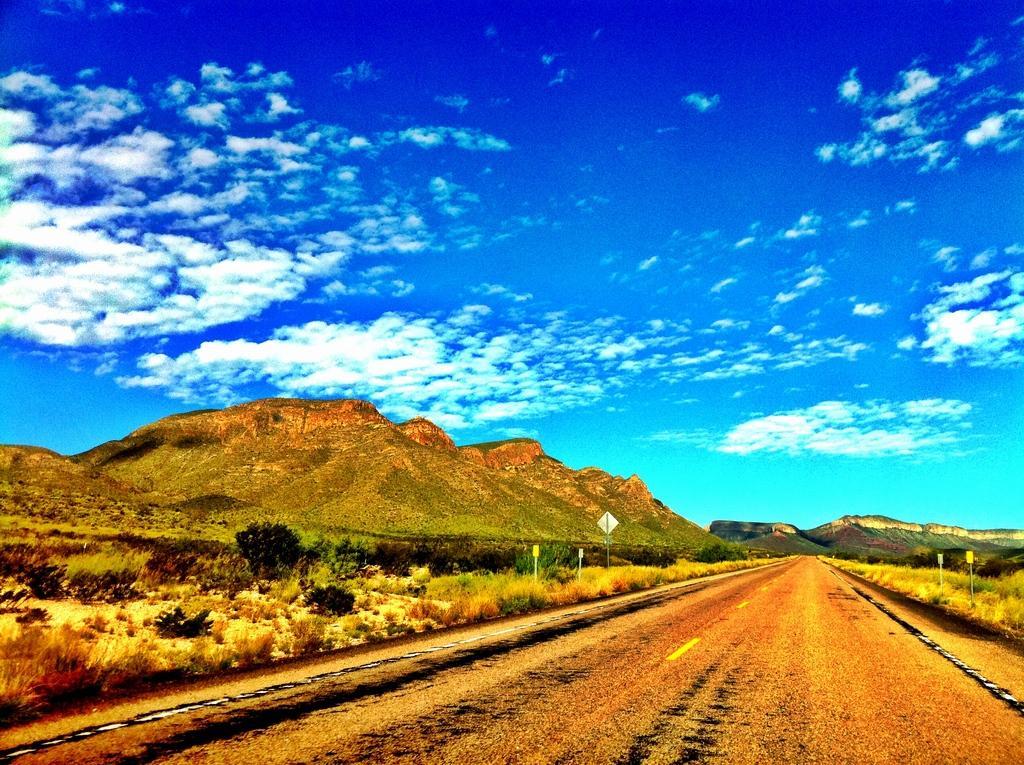In one or two sentences, can you explain what this image depicts? In this picture there are mountains and trees and poles and there are boards on the poles. At the top there is sky and there are clouds. At the bottom there is a road and there are plants and there is grass. 